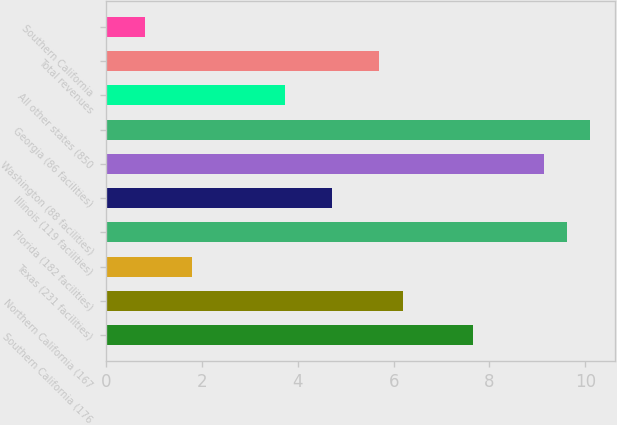Convert chart to OTSL. <chart><loc_0><loc_0><loc_500><loc_500><bar_chart><fcel>Southern California (176<fcel>Northern California (167<fcel>Texas (231 facilities)<fcel>Florida (182 facilities)<fcel>Illinois (119 facilities)<fcel>Washington (88 facilities)<fcel>Georgia (86 facilities)<fcel>All other states (850<fcel>Total revenues<fcel>Southern California<nl><fcel>7.66<fcel>6.19<fcel>1.78<fcel>9.62<fcel>4.72<fcel>9.13<fcel>10.11<fcel>3.74<fcel>5.7<fcel>0.8<nl></chart> 